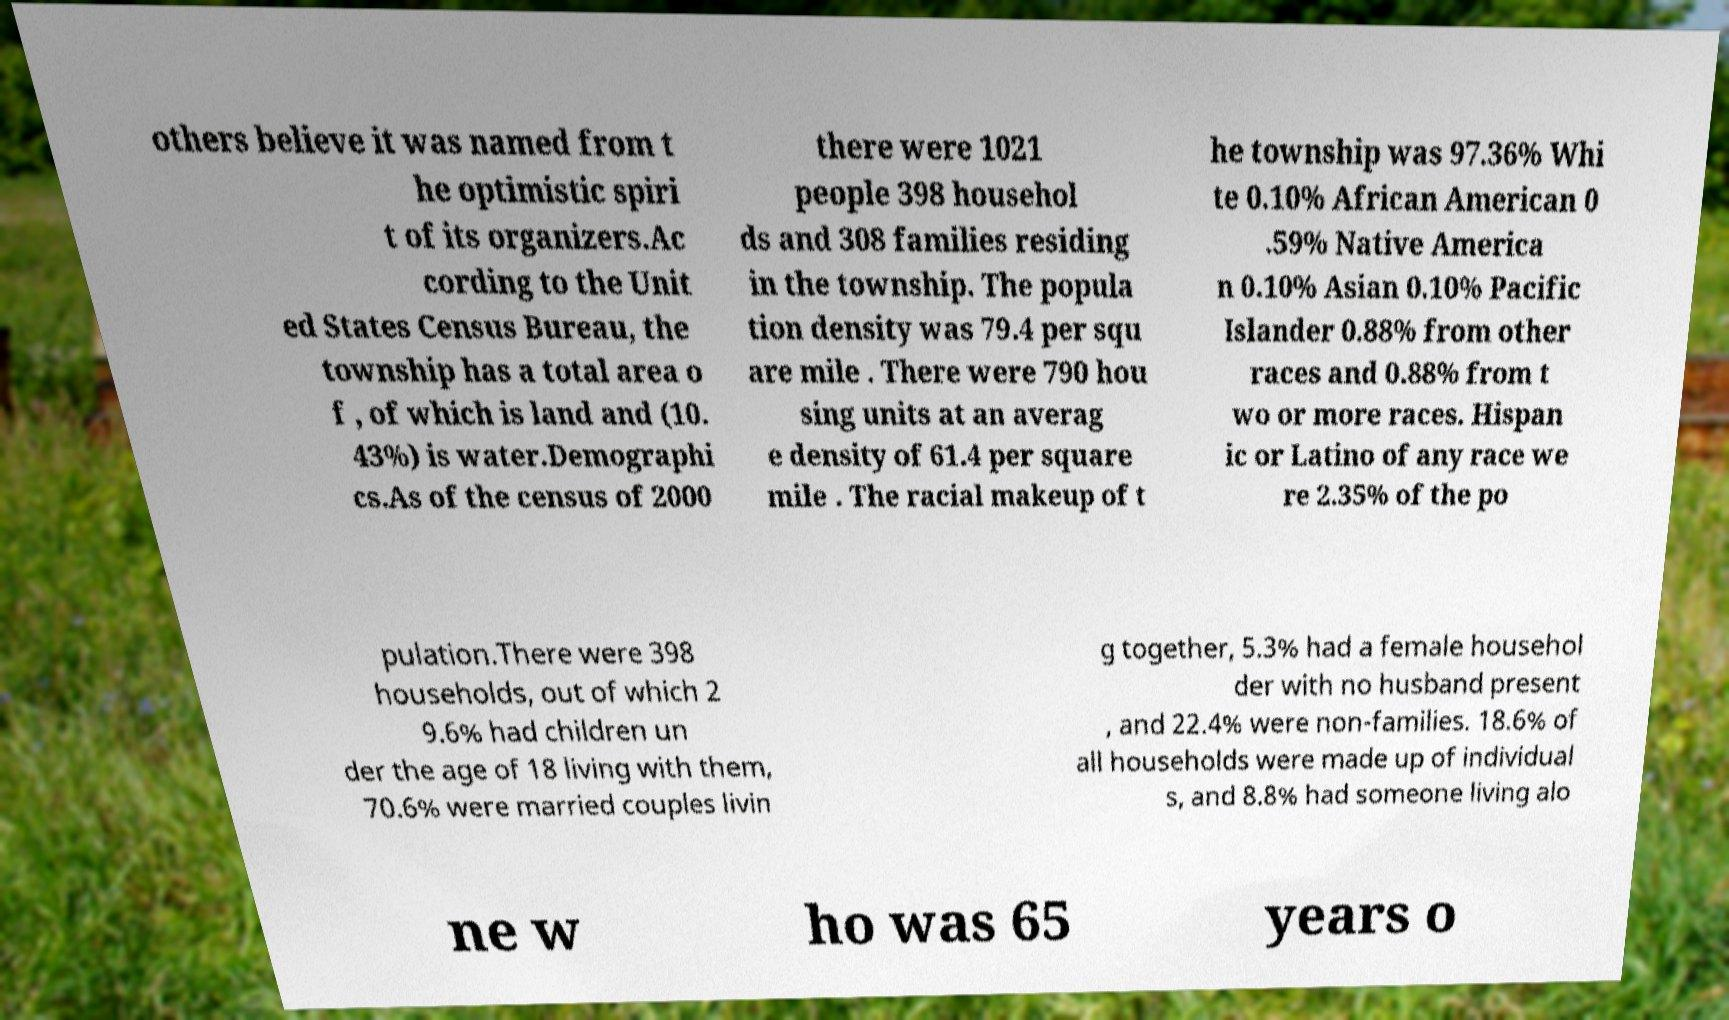Can you read and provide the text displayed in the image?This photo seems to have some interesting text. Can you extract and type it out for me? others believe it was named from t he optimistic spiri t of its organizers.Ac cording to the Unit ed States Census Bureau, the township has a total area o f , of which is land and (10. 43%) is water.Demographi cs.As of the census of 2000 there were 1021 people 398 househol ds and 308 families residing in the township. The popula tion density was 79.4 per squ are mile . There were 790 hou sing units at an averag e density of 61.4 per square mile . The racial makeup of t he township was 97.36% Whi te 0.10% African American 0 .59% Native America n 0.10% Asian 0.10% Pacific Islander 0.88% from other races and 0.88% from t wo or more races. Hispan ic or Latino of any race we re 2.35% of the po pulation.There were 398 households, out of which 2 9.6% had children un der the age of 18 living with them, 70.6% were married couples livin g together, 5.3% had a female househol der with no husband present , and 22.4% were non-families. 18.6% of all households were made up of individual s, and 8.8% had someone living alo ne w ho was 65 years o 